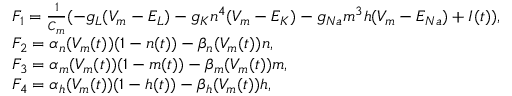<formula> <loc_0><loc_0><loc_500><loc_500>\begin{array} { r l } & { F _ { 1 } = \frac { 1 } { C _ { m } } ( - g _ { L } ( V _ { m } - E _ { L } ) - g _ { K } n ^ { 4 } ( V _ { m } - E _ { K } ) - g _ { N a } m ^ { 3 } h ( V _ { m } - E _ { N a } ) + I ( t ) ) , } \\ & { F _ { 2 } = \alpha _ { n } ( V _ { m } ( t ) ) ( 1 - n ( t ) ) - \beta _ { n } ( V _ { m } ( t ) ) n , } \\ & { F _ { 3 } = \alpha _ { m } ( V _ { m } ( t ) ) ( 1 - m ( t ) ) - \beta _ { m } ( V _ { m } ( t ) ) m , } \\ & { F _ { 4 } = \alpha _ { h } ( V _ { m } ( t ) ) ( 1 - h ( t ) ) - \beta _ { h } ( V _ { m } ( t ) ) h , } \end{array}</formula> 